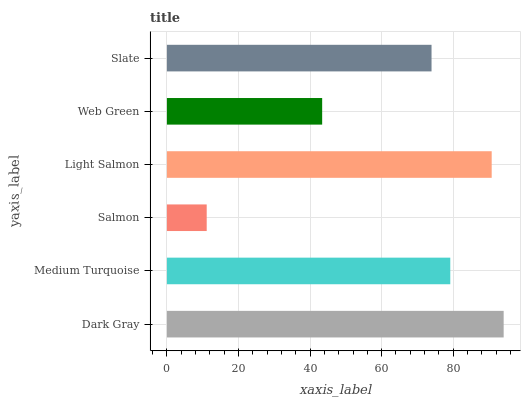Is Salmon the minimum?
Answer yes or no. Yes. Is Dark Gray the maximum?
Answer yes or no. Yes. Is Medium Turquoise the minimum?
Answer yes or no. No. Is Medium Turquoise the maximum?
Answer yes or no. No. Is Dark Gray greater than Medium Turquoise?
Answer yes or no. Yes. Is Medium Turquoise less than Dark Gray?
Answer yes or no. Yes. Is Medium Turquoise greater than Dark Gray?
Answer yes or no. No. Is Dark Gray less than Medium Turquoise?
Answer yes or no. No. Is Medium Turquoise the high median?
Answer yes or no. Yes. Is Slate the low median?
Answer yes or no. Yes. Is Light Salmon the high median?
Answer yes or no. No. Is Web Green the low median?
Answer yes or no. No. 